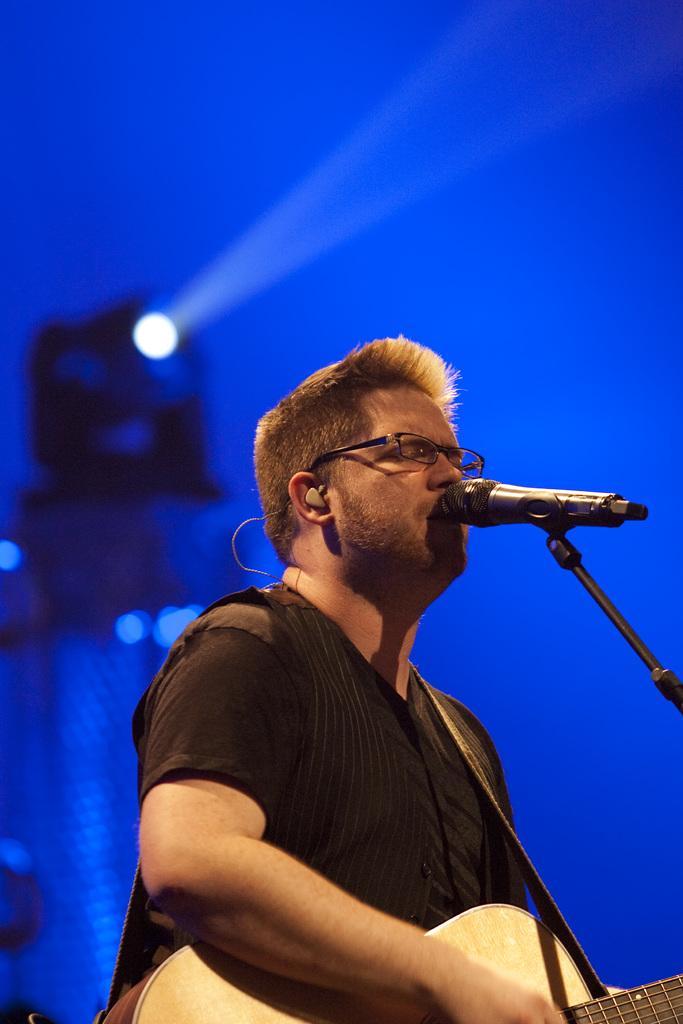Please provide a concise description of this image. This is a picture of a man, the man is singing a song and holding a guitar. This is a microphone and the stand background of the man is a blue color with a light. 